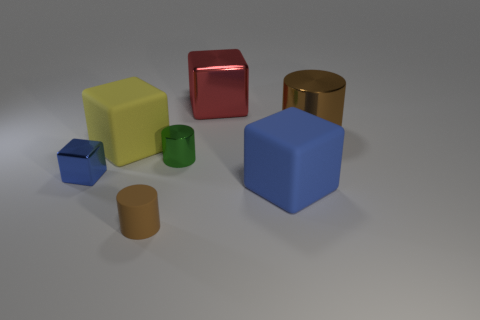Subtract all yellow cubes. How many cubes are left? 3 Subtract all red cubes. How many cubes are left? 3 Add 2 metal things. How many objects exist? 9 Subtract all purple cubes. Subtract all purple balls. How many cubes are left? 4 Subtract all blocks. How many objects are left? 3 Add 7 purple cylinders. How many purple cylinders exist? 7 Subtract 0 purple cubes. How many objects are left? 7 Subtract all blue rubber objects. Subtract all metal objects. How many objects are left? 2 Add 4 blue rubber objects. How many blue rubber objects are left? 5 